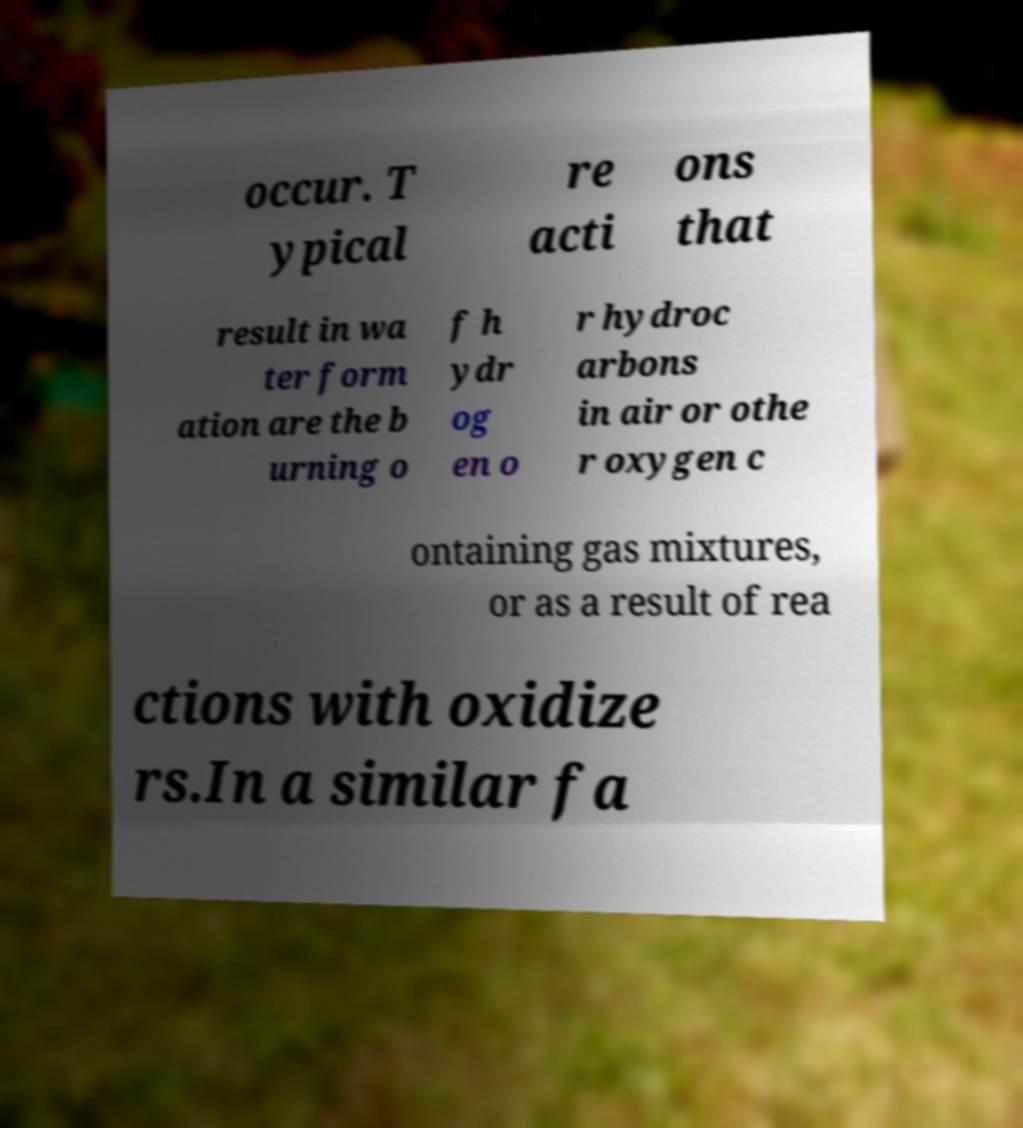For documentation purposes, I need the text within this image transcribed. Could you provide that? occur. T ypical re acti ons that result in wa ter form ation are the b urning o f h ydr og en o r hydroc arbons in air or othe r oxygen c ontaining gas mixtures, or as a result of rea ctions with oxidize rs.In a similar fa 